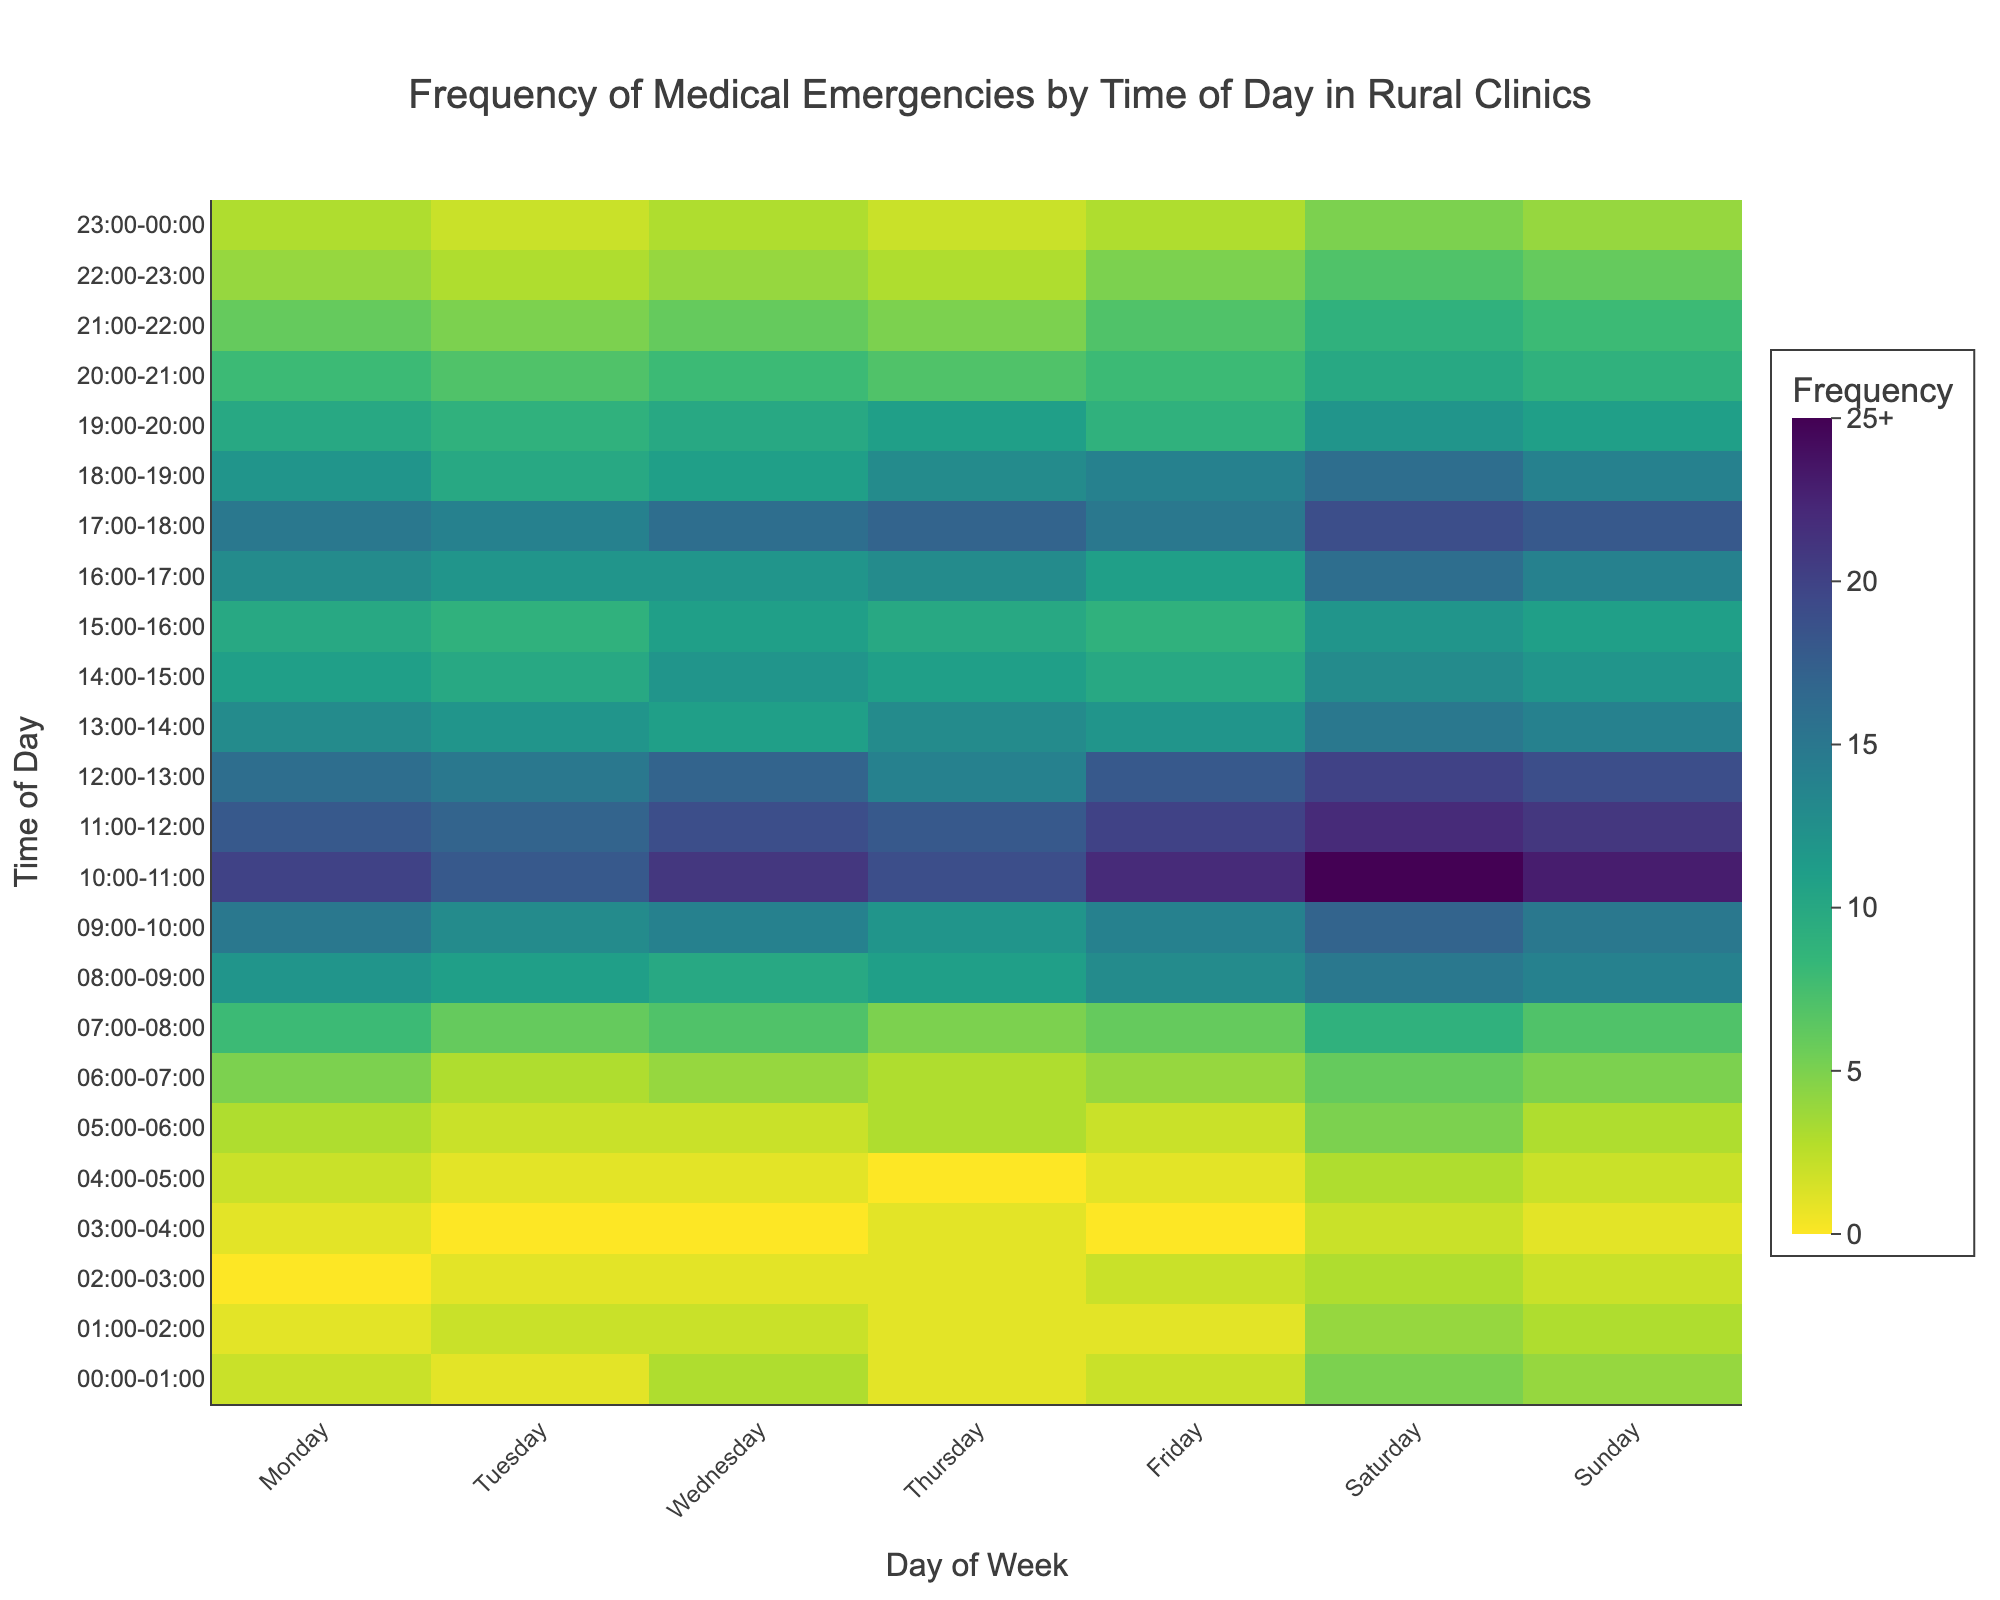What is the title of the heatmap? The title is located at the top of the figure and provides a summary of the figure's content.
Answer: 'Frequency of Medical Emergencies by Time of Day in Rural Clinics' Which day of the week typically has the highest frequency of medical emergencies between 10:00 and 11:00? Look at the row corresponding to 10:00-11:00 and compare the frequencies for each day.
Answer: Saturday How many times does the frequency value reach or exceed 20 for any given time slot? Go through each cell in the heatmap and count how many times the value is equal to or more than 20.
Answer: 7 Which time slot on Monday has the highest frequency of medical emergencies? Review the column corresponding to Monday and identify the cell with the highest value.
Answer: 10:00-11:00 On which day does the time slot from 18:00-19:00 have the lowest frequency? Look at the row for 18:00-19:00 and find the column with the lowest frequency value.
Answer: Tuesday Is the frequency of medical emergencies higher at midnight (00:00-01:00) on Saturday compared to Sunday? Compare the values for 00:00-01:00 on Saturday and Sunday.
Answer: No How many more emergencies are recorded from 16:00-17:00 on Thursday compared to Monday? Subtract the frequency of 16:00-17:00 on Monday from that on Thursday.
Answer: 0 During which time slot on Friday do medical emergencies first exceed 10? Explore the Friday column and identify the earliest time slot where the value exceeds 10.
Answer: 08:00-09:00 Which day has the overall highest frequency of emergencies in the morning (06:00-12:00)? Summarize the frequencies for each day from 06:00 to 12:00 and compare the totals to find the highest.
Answer: Saturday Is there any time slot on Wednesday where the frequency of emergencies reaches exactly 19? Check each cell in the Wednesday column to see if any contain the value 19.
Answer: No 